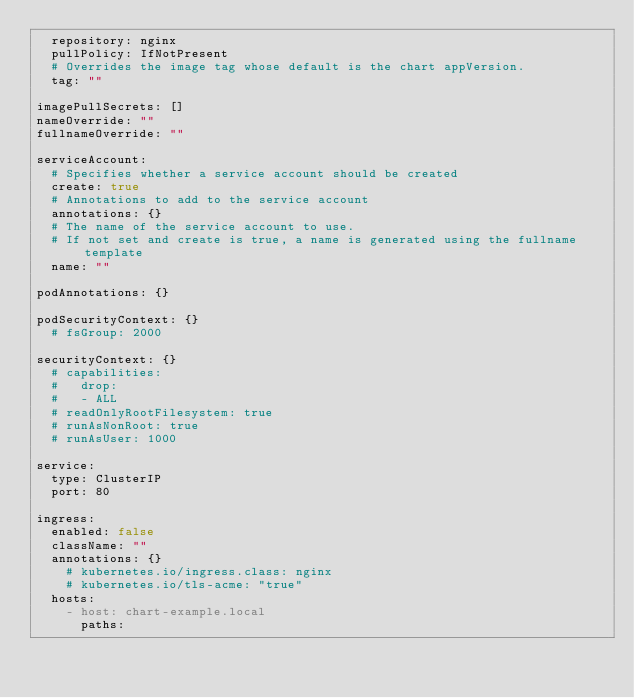Convert code to text. <code><loc_0><loc_0><loc_500><loc_500><_YAML_>  repository: nginx
  pullPolicy: IfNotPresent
  # Overrides the image tag whose default is the chart appVersion.
  tag: ""

imagePullSecrets: []
nameOverride: ""
fullnameOverride: ""

serviceAccount:
  # Specifies whether a service account should be created
  create: true
  # Annotations to add to the service account
  annotations: {}
  # The name of the service account to use.
  # If not set and create is true, a name is generated using the fullname template
  name: ""

podAnnotations: {}

podSecurityContext: {}
  # fsGroup: 2000

securityContext: {}
  # capabilities:
  #   drop:
  #   - ALL
  # readOnlyRootFilesystem: true
  # runAsNonRoot: true
  # runAsUser: 1000

service:
  type: ClusterIP
  port: 80

ingress:
  enabled: false
  className: ""
  annotations: {}
    # kubernetes.io/ingress.class: nginx
    # kubernetes.io/tls-acme: "true"
  hosts:
    - host: chart-example.local
      paths:</code> 